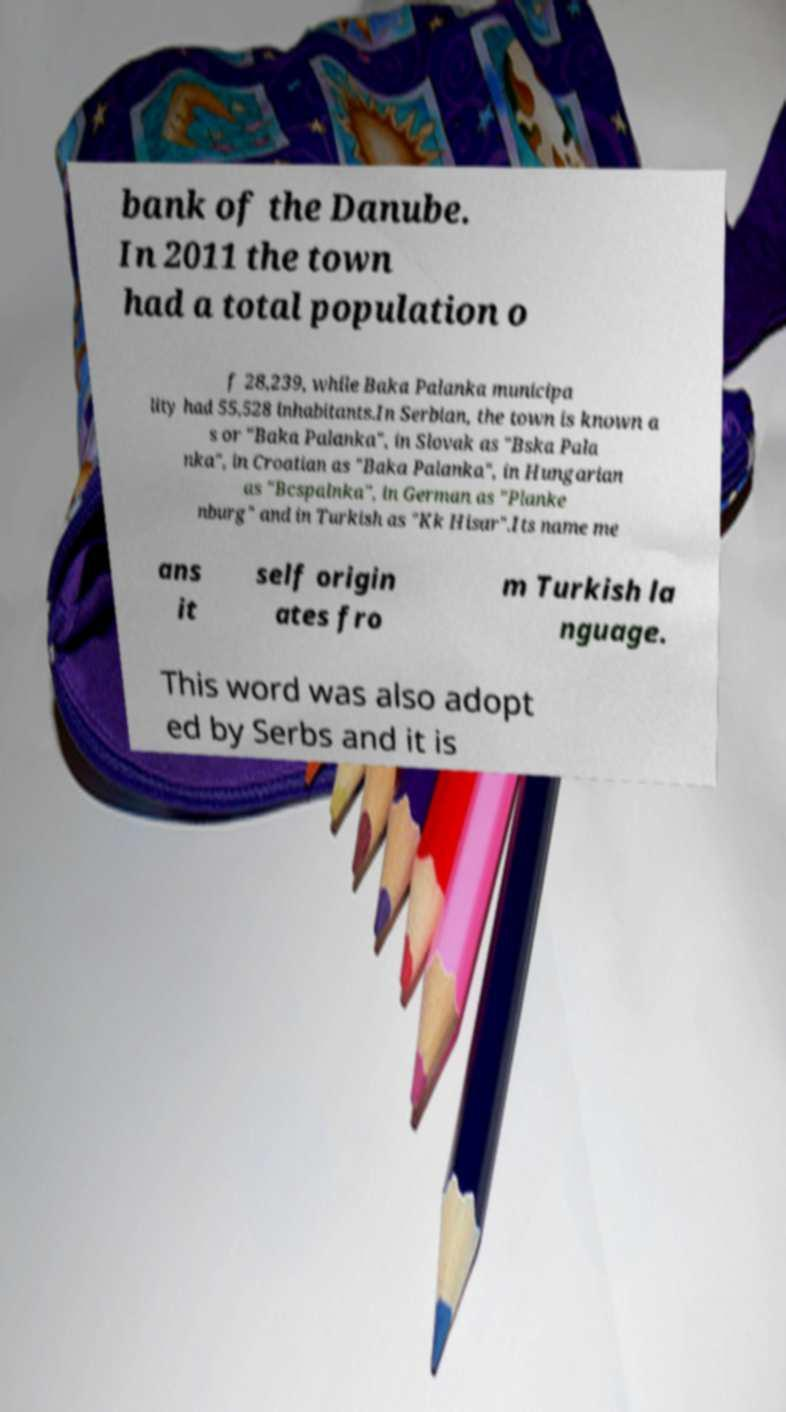There's text embedded in this image that I need extracted. Can you transcribe it verbatim? bank of the Danube. In 2011 the town had a total population o f 28,239, while Baka Palanka municipa lity had 55,528 inhabitants.In Serbian, the town is known a s or "Baka Palanka", in Slovak as "Bska Pala nka", in Croatian as "Baka Palanka", in Hungarian as "Bcspalnka", in German as "Planke nburg" and in Turkish as "Kk Hisar".Its name me ans it self origin ates fro m Turkish la nguage. This word was also adopt ed by Serbs and it is 